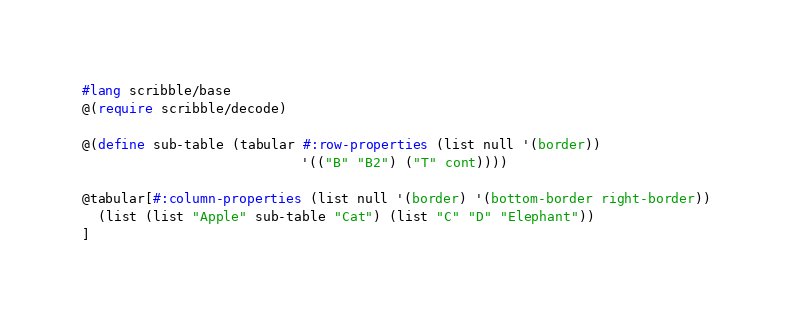<code> <loc_0><loc_0><loc_500><loc_500><_Racket_>#lang scribble/base
@(require scribble/decode)

@(define sub-table (tabular #:row-properties (list null '(border))
                            '(("B" "B2") ("T" cont))))

@tabular[#:column-properties (list null '(border) '(bottom-border right-border))
  (list (list "Apple" sub-table "Cat") (list "C" "D" "Elephant"))
]
</code> 